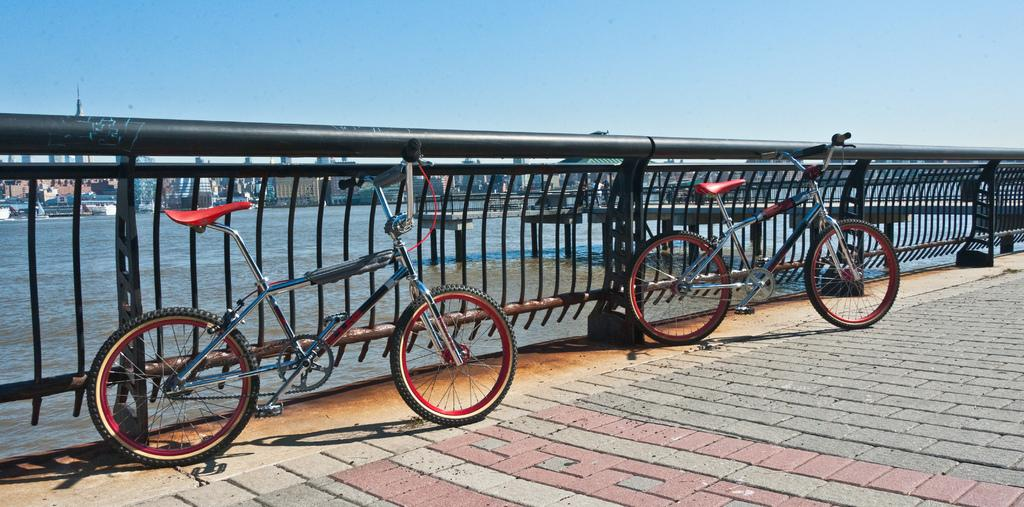How many bicycles can be seen in the image? There are two bicycles in the image. What is the color of the fence in the image? The fence in the image is black. What can be seen in the background of the image? There are buildings in the background of the image. What is the color of the sky in the image? The sky is blue and visible at the top of the image. What type of company does the toad own in the image? There is no toad or company present in the image. What kind of beast can be seen interacting with the bicycles in the image? There are no beasts present in the image; only the bicycles, fence, water, buildings, and sky are visible. 